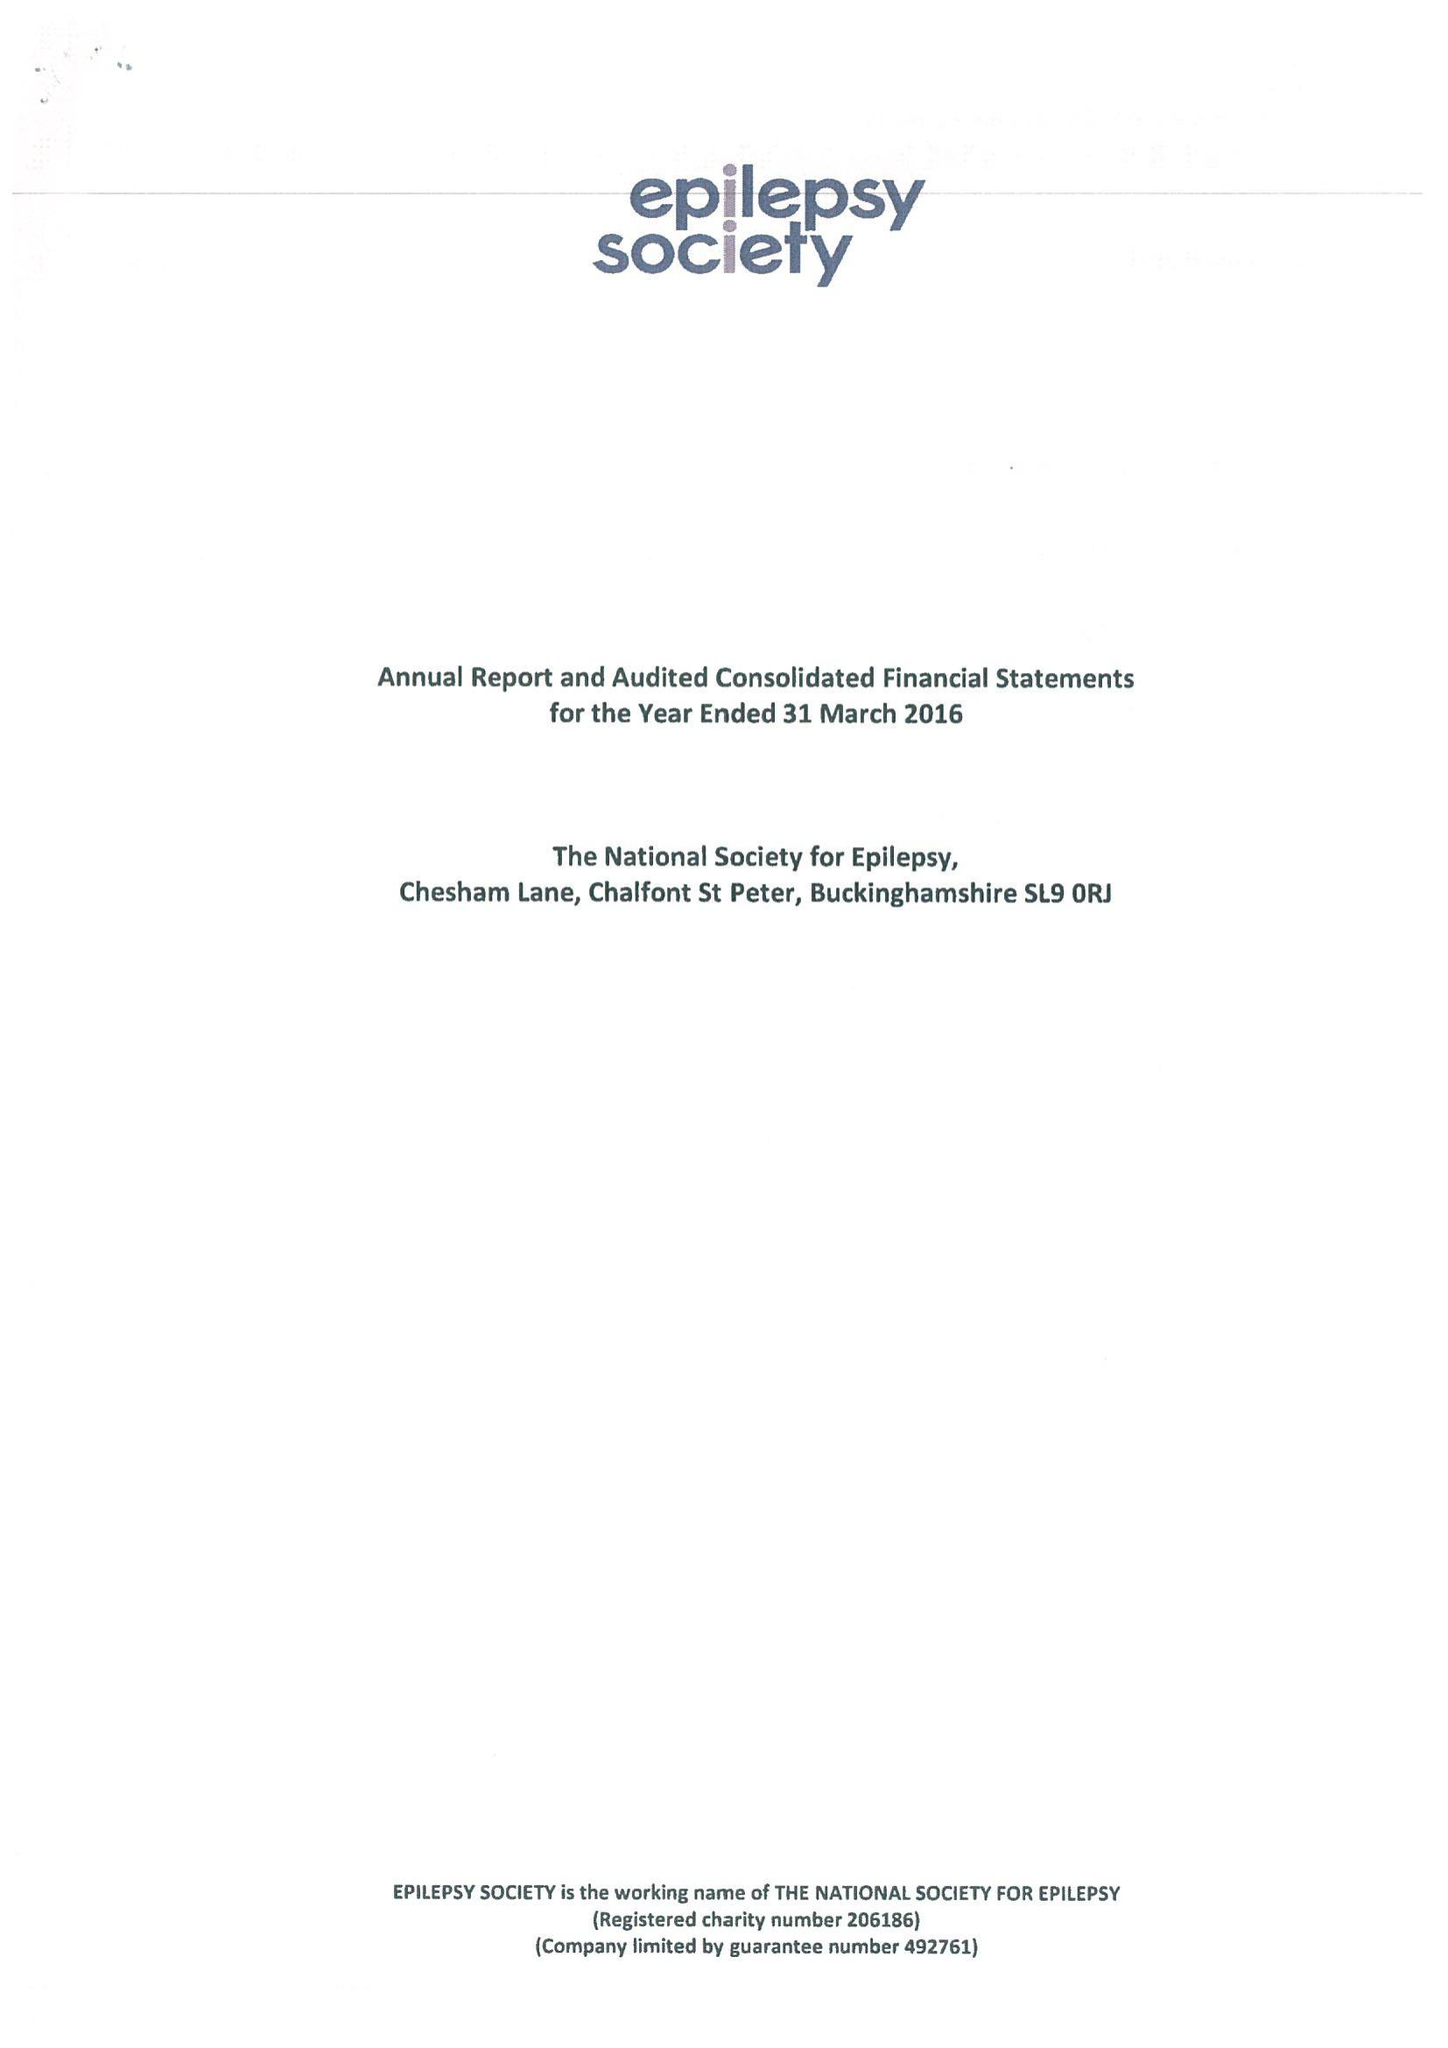What is the value for the charity_name?
Answer the question using a single word or phrase. Epilepsy Society 